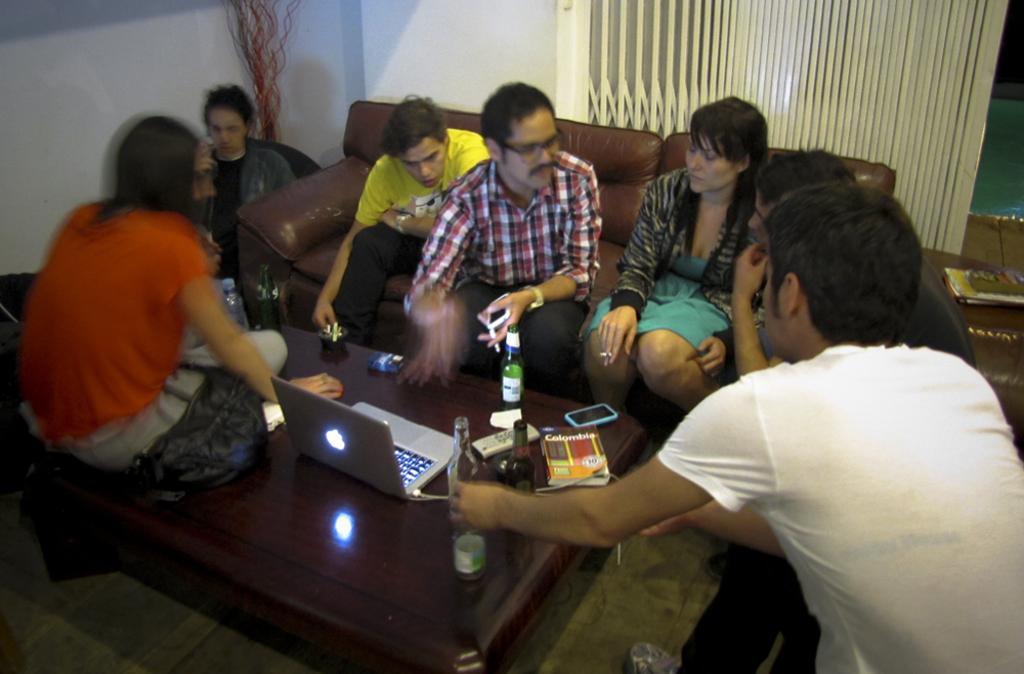How would you summarize this image in a sentence or two? There are group of people sitting in a sofa and there is a table in front of them where one lady sat on it and there is a mac book and some drink bottles and mobile phone on it. 